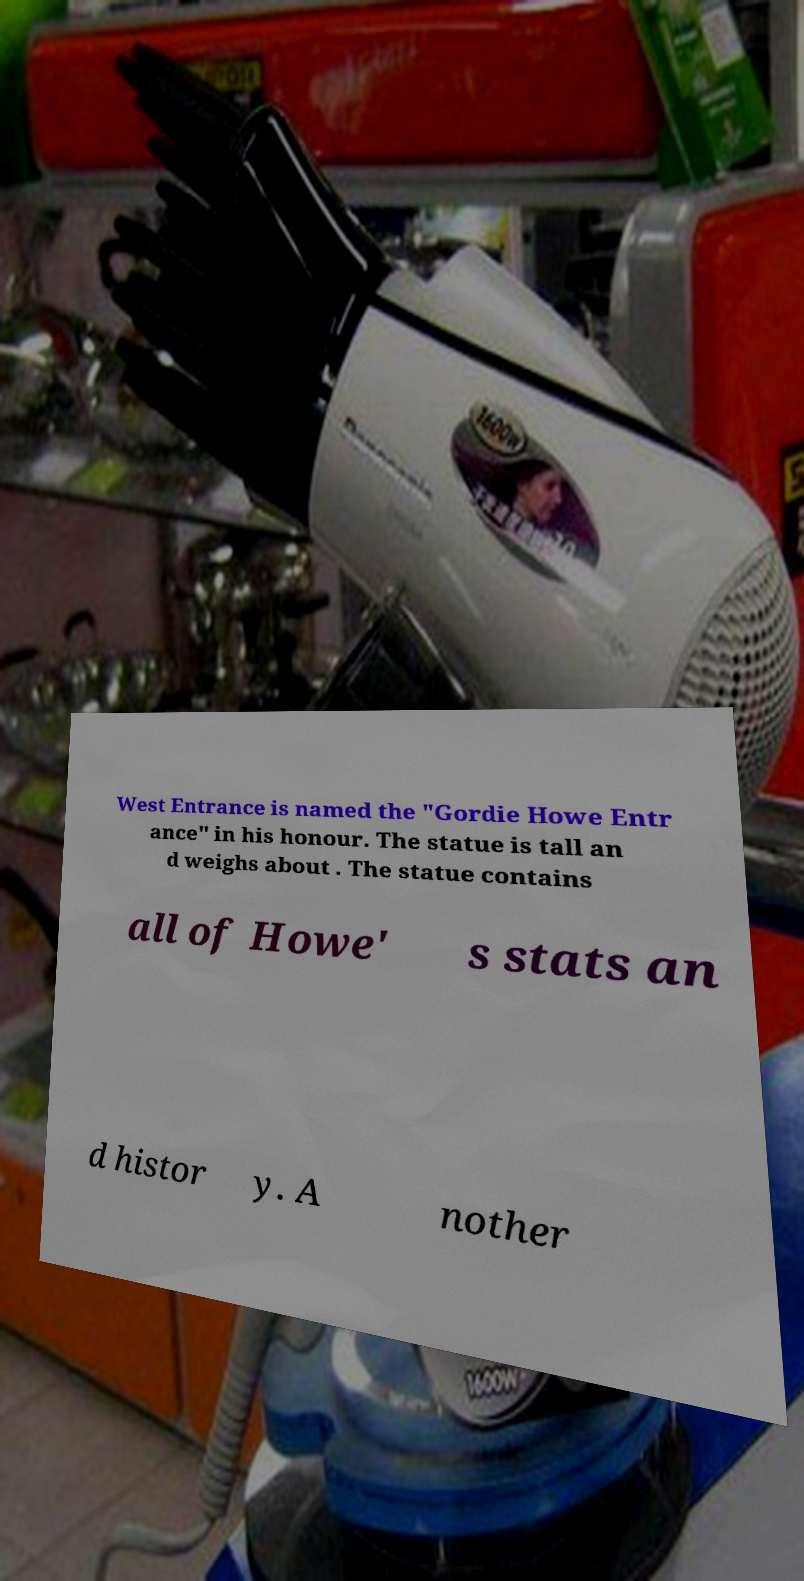There's text embedded in this image that I need extracted. Can you transcribe it verbatim? West Entrance is named the "Gordie Howe Entr ance" in his honour. The statue is tall an d weighs about . The statue contains all of Howe' s stats an d histor y. A nother 